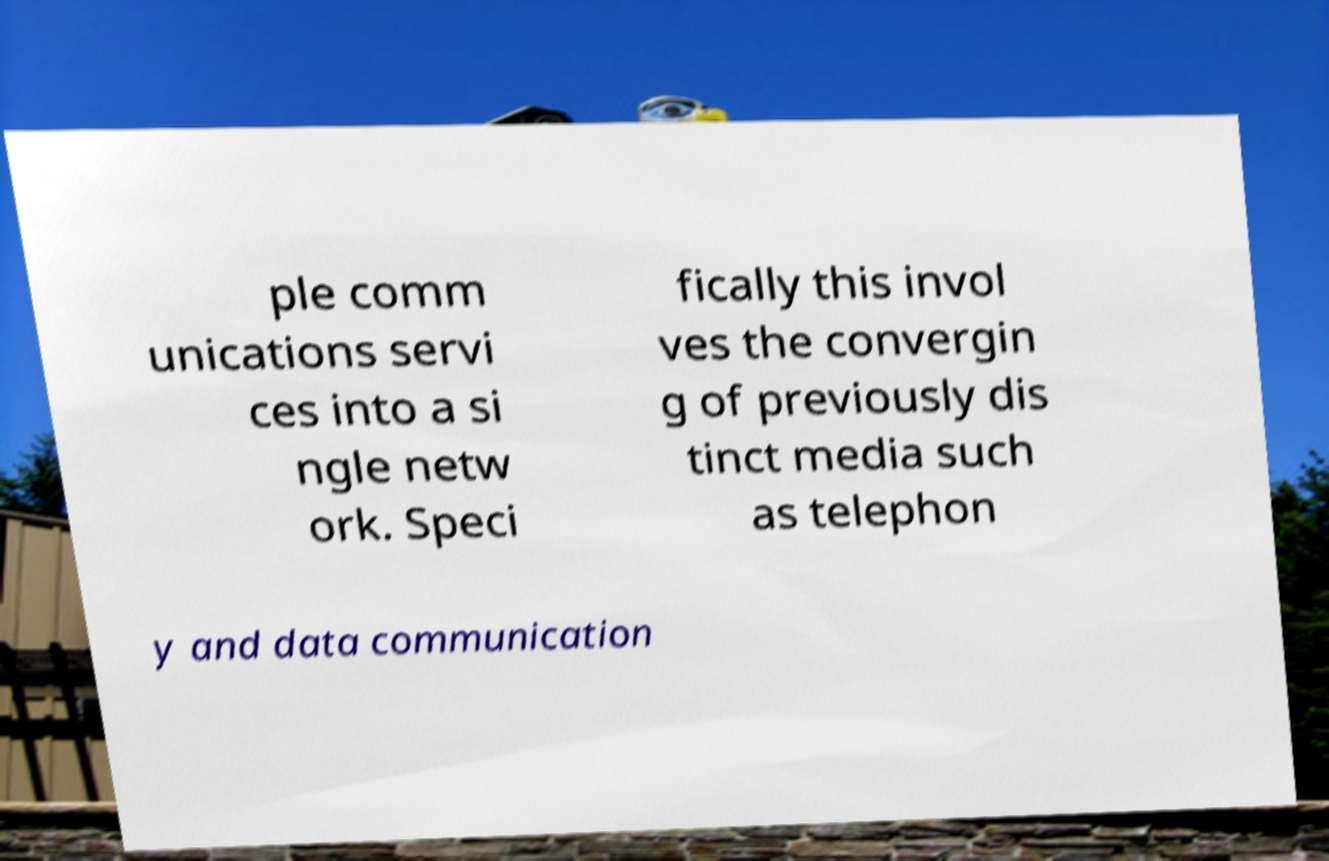Can you read and provide the text displayed in the image?This photo seems to have some interesting text. Can you extract and type it out for me? ple comm unications servi ces into a si ngle netw ork. Speci fically this invol ves the convergin g of previously dis tinct media such as telephon y and data communication 